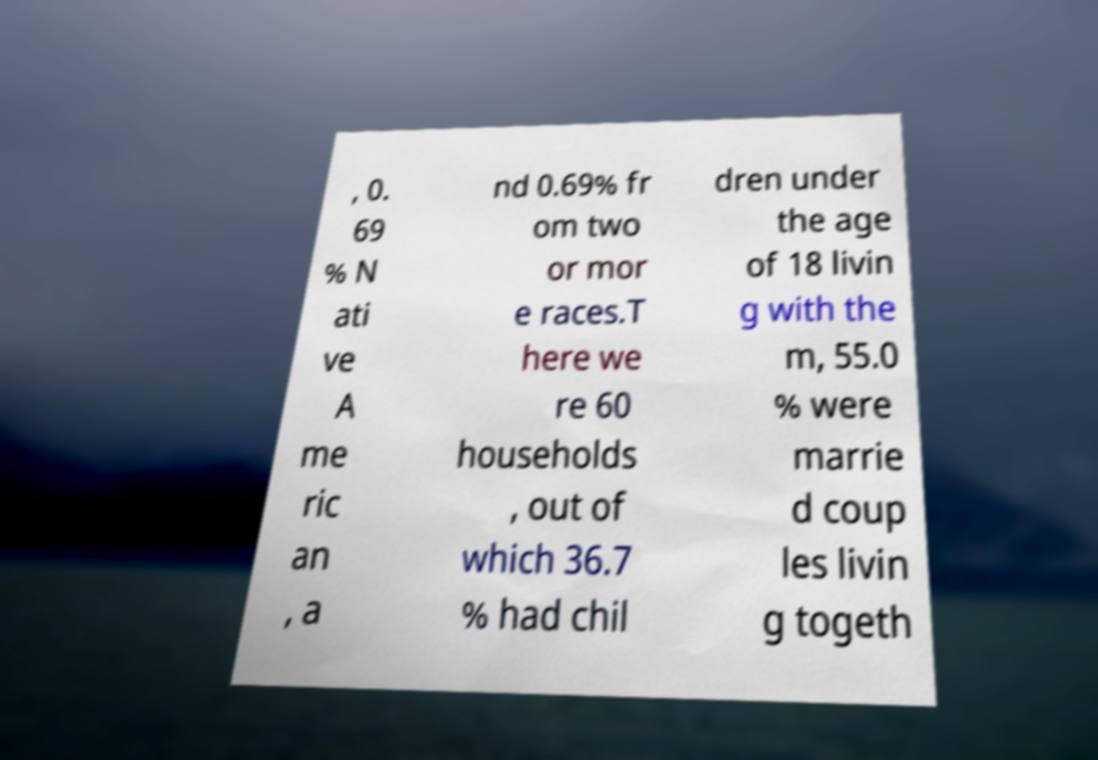There's text embedded in this image that I need extracted. Can you transcribe it verbatim? , 0. 69 % N ati ve A me ric an , a nd 0.69% fr om two or mor e races.T here we re 60 households , out of which 36.7 % had chil dren under the age of 18 livin g with the m, 55.0 % were marrie d coup les livin g togeth 